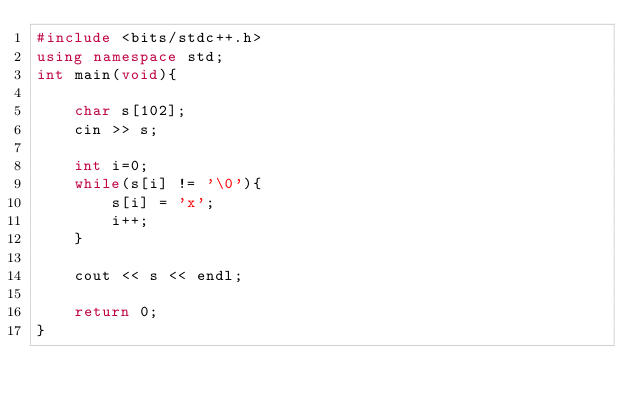<code> <loc_0><loc_0><loc_500><loc_500><_C++_>#include <bits/stdc++.h>
using namespace std;
int main(void){
    
    char s[102];
    cin >> s;
    
    int i=0;
    while(s[i] != '\0'){
        s[i] = 'x';
        i++;
    }
    
    cout << s << endl;
    
    return 0;
}
</code> 